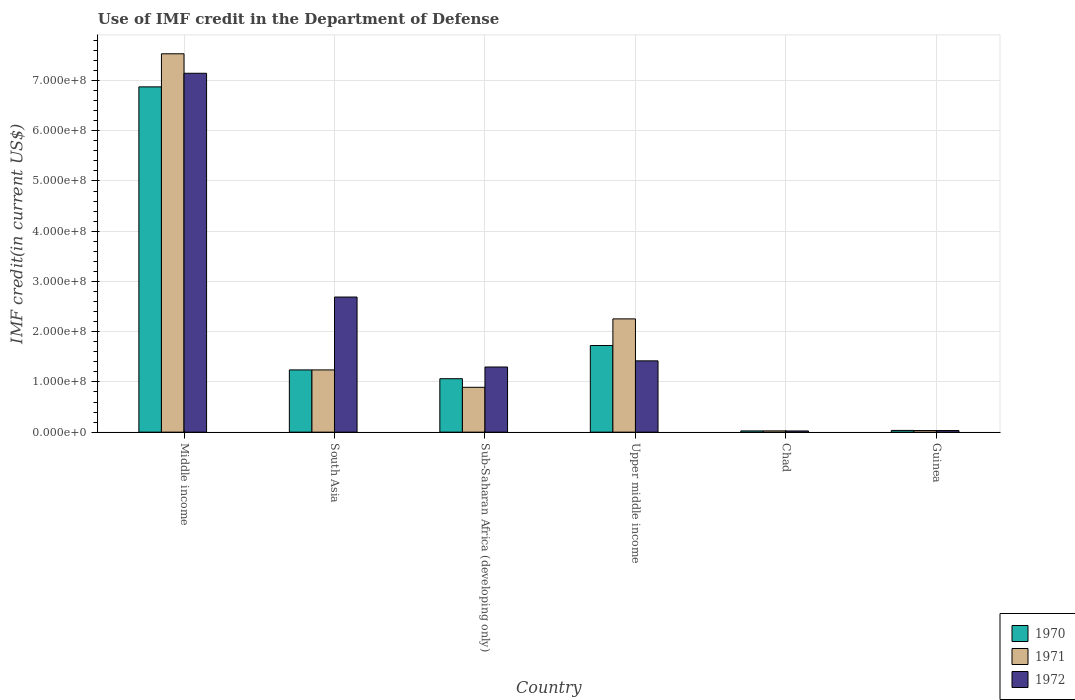How many different coloured bars are there?
Provide a succinct answer. 3. How many groups of bars are there?
Provide a short and direct response. 6. How many bars are there on the 6th tick from the right?
Provide a short and direct response. 3. What is the label of the 4th group of bars from the left?
Give a very brief answer. Upper middle income. In how many cases, is the number of bars for a given country not equal to the number of legend labels?
Make the answer very short. 0. What is the IMF credit in the Department of Defense in 1971 in Sub-Saharan Africa (developing only)?
Your response must be concise. 8.93e+07. Across all countries, what is the maximum IMF credit in the Department of Defense in 1972?
Give a very brief answer. 7.14e+08. Across all countries, what is the minimum IMF credit in the Department of Defense in 1972?
Give a very brief answer. 2.37e+06. In which country was the IMF credit in the Department of Defense in 1972 minimum?
Give a very brief answer. Chad. What is the total IMF credit in the Department of Defense in 1971 in the graph?
Make the answer very short. 1.20e+09. What is the difference between the IMF credit in the Department of Defense in 1972 in Middle income and that in Sub-Saharan Africa (developing only)?
Offer a very short reply. 5.85e+08. What is the difference between the IMF credit in the Department of Defense in 1970 in Middle income and the IMF credit in the Department of Defense in 1971 in Sub-Saharan Africa (developing only)?
Offer a terse response. 5.98e+08. What is the average IMF credit in the Department of Defense in 1972 per country?
Make the answer very short. 2.10e+08. What is the difference between the IMF credit in the Department of Defense of/in 1971 and IMF credit in the Department of Defense of/in 1972 in Upper middle income?
Your answer should be compact. 8.35e+07. In how many countries, is the IMF credit in the Department of Defense in 1972 greater than 300000000 US$?
Your answer should be very brief. 1. What is the ratio of the IMF credit in the Department of Defense in 1970 in Middle income to that in South Asia?
Ensure brevity in your answer.  5.55. Is the difference between the IMF credit in the Department of Defense in 1971 in Guinea and Sub-Saharan Africa (developing only) greater than the difference between the IMF credit in the Department of Defense in 1972 in Guinea and Sub-Saharan Africa (developing only)?
Your response must be concise. Yes. What is the difference between the highest and the second highest IMF credit in the Department of Defense in 1972?
Your answer should be compact. -4.45e+08. What is the difference between the highest and the lowest IMF credit in the Department of Defense in 1971?
Make the answer very short. 7.51e+08. Is the sum of the IMF credit in the Department of Defense in 1971 in Guinea and Middle income greater than the maximum IMF credit in the Department of Defense in 1972 across all countries?
Your response must be concise. Yes. What does the 2nd bar from the left in Sub-Saharan Africa (developing only) represents?
Make the answer very short. 1971. What does the 2nd bar from the right in Middle income represents?
Make the answer very short. 1971. Is it the case that in every country, the sum of the IMF credit in the Department of Defense in 1971 and IMF credit in the Department of Defense in 1972 is greater than the IMF credit in the Department of Defense in 1970?
Keep it short and to the point. Yes. How many bars are there?
Your answer should be very brief. 18. Are all the bars in the graph horizontal?
Give a very brief answer. No. How many countries are there in the graph?
Your response must be concise. 6. What is the difference between two consecutive major ticks on the Y-axis?
Keep it short and to the point. 1.00e+08. Are the values on the major ticks of Y-axis written in scientific E-notation?
Keep it short and to the point. Yes. Does the graph contain any zero values?
Provide a short and direct response. No. How many legend labels are there?
Make the answer very short. 3. What is the title of the graph?
Offer a terse response. Use of IMF credit in the Department of Defense. What is the label or title of the X-axis?
Make the answer very short. Country. What is the label or title of the Y-axis?
Your answer should be compact. IMF credit(in current US$). What is the IMF credit(in current US$) in 1970 in Middle income?
Ensure brevity in your answer.  6.87e+08. What is the IMF credit(in current US$) of 1971 in Middle income?
Offer a very short reply. 7.53e+08. What is the IMF credit(in current US$) in 1972 in Middle income?
Your response must be concise. 7.14e+08. What is the IMF credit(in current US$) of 1970 in South Asia?
Ensure brevity in your answer.  1.24e+08. What is the IMF credit(in current US$) in 1971 in South Asia?
Provide a short and direct response. 1.24e+08. What is the IMF credit(in current US$) of 1972 in South Asia?
Offer a terse response. 2.69e+08. What is the IMF credit(in current US$) of 1970 in Sub-Saharan Africa (developing only)?
Provide a short and direct response. 1.06e+08. What is the IMF credit(in current US$) in 1971 in Sub-Saharan Africa (developing only)?
Give a very brief answer. 8.93e+07. What is the IMF credit(in current US$) in 1972 in Sub-Saharan Africa (developing only)?
Offer a very short reply. 1.30e+08. What is the IMF credit(in current US$) in 1970 in Upper middle income?
Provide a succinct answer. 1.72e+08. What is the IMF credit(in current US$) of 1971 in Upper middle income?
Ensure brevity in your answer.  2.25e+08. What is the IMF credit(in current US$) of 1972 in Upper middle income?
Your response must be concise. 1.42e+08. What is the IMF credit(in current US$) in 1970 in Chad?
Offer a very short reply. 2.47e+06. What is the IMF credit(in current US$) in 1971 in Chad?
Your answer should be very brief. 2.52e+06. What is the IMF credit(in current US$) in 1972 in Chad?
Provide a succinct answer. 2.37e+06. What is the IMF credit(in current US$) of 1970 in Guinea?
Offer a very short reply. 3.45e+06. What is the IMF credit(in current US$) of 1971 in Guinea?
Your answer should be very brief. 3.20e+06. What is the IMF credit(in current US$) in 1972 in Guinea?
Provide a short and direct response. 3.20e+06. Across all countries, what is the maximum IMF credit(in current US$) in 1970?
Keep it short and to the point. 6.87e+08. Across all countries, what is the maximum IMF credit(in current US$) in 1971?
Offer a very short reply. 7.53e+08. Across all countries, what is the maximum IMF credit(in current US$) of 1972?
Offer a very short reply. 7.14e+08. Across all countries, what is the minimum IMF credit(in current US$) of 1970?
Your answer should be compact. 2.47e+06. Across all countries, what is the minimum IMF credit(in current US$) in 1971?
Provide a succinct answer. 2.52e+06. Across all countries, what is the minimum IMF credit(in current US$) of 1972?
Make the answer very short. 2.37e+06. What is the total IMF credit(in current US$) in 1970 in the graph?
Your response must be concise. 1.10e+09. What is the total IMF credit(in current US$) in 1971 in the graph?
Your response must be concise. 1.20e+09. What is the total IMF credit(in current US$) of 1972 in the graph?
Your answer should be very brief. 1.26e+09. What is the difference between the IMF credit(in current US$) of 1970 in Middle income and that in South Asia?
Keep it short and to the point. 5.64e+08. What is the difference between the IMF credit(in current US$) in 1971 in Middle income and that in South Asia?
Provide a succinct answer. 6.29e+08. What is the difference between the IMF credit(in current US$) of 1972 in Middle income and that in South Asia?
Ensure brevity in your answer.  4.45e+08. What is the difference between the IMF credit(in current US$) in 1970 in Middle income and that in Sub-Saharan Africa (developing only)?
Provide a short and direct response. 5.81e+08. What is the difference between the IMF credit(in current US$) of 1971 in Middle income and that in Sub-Saharan Africa (developing only)?
Make the answer very short. 6.64e+08. What is the difference between the IMF credit(in current US$) of 1972 in Middle income and that in Sub-Saharan Africa (developing only)?
Your answer should be compact. 5.85e+08. What is the difference between the IMF credit(in current US$) of 1970 in Middle income and that in Upper middle income?
Your answer should be very brief. 5.15e+08. What is the difference between the IMF credit(in current US$) in 1971 in Middle income and that in Upper middle income?
Offer a very short reply. 5.28e+08. What is the difference between the IMF credit(in current US$) in 1972 in Middle income and that in Upper middle income?
Offer a terse response. 5.73e+08. What is the difference between the IMF credit(in current US$) in 1970 in Middle income and that in Chad?
Give a very brief answer. 6.85e+08. What is the difference between the IMF credit(in current US$) in 1971 in Middle income and that in Chad?
Give a very brief answer. 7.51e+08. What is the difference between the IMF credit(in current US$) of 1972 in Middle income and that in Chad?
Offer a very short reply. 7.12e+08. What is the difference between the IMF credit(in current US$) in 1970 in Middle income and that in Guinea?
Offer a terse response. 6.84e+08. What is the difference between the IMF credit(in current US$) in 1971 in Middle income and that in Guinea?
Ensure brevity in your answer.  7.50e+08. What is the difference between the IMF credit(in current US$) in 1972 in Middle income and that in Guinea?
Your answer should be compact. 7.11e+08. What is the difference between the IMF credit(in current US$) of 1970 in South Asia and that in Sub-Saharan Africa (developing only)?
Your answer should be very brief. 1.75e+07. What is the difference between the IMF credit(in current US$) in 1971 in South Asia and that in Sub-Saharan Africa (developing only)?
Provide a short and direct response. 3.46e+07. What is the difference between the IMF credit(in current US$) in 1972 in South Asia and that in Sub-Saharan Africa (developing only)?
Provide a succinct answer. 1.39e+08. What is the difference between the IMF credit(in current US$) in 1970 in South Asia and that in Upper middle income?
Provide a succinct answer. -4.86e+07. What is the difference between the IMF credit(in current US$) of 1971 in South Asia and that in Upper middle income?
Give a very brief answer. -1.02e+08. What is the difference between the IMF credit(in current US$) in 1972 in South Asia and that in Upper middle income?
Give a very brief answer. 1.27e+08. What is the difference between the IMF credit(in current US$) of 1970 in South Asia and that in Chad?
Your answer should be compact. 1.21e+08. What is the difference between the IMF credit(in current US$) of 1971 in South Asia and that in Chad?
Make the answer very short. 1.21e+08. What is the difference between the IMF credit(in current US$) of 1972 in South Asia and that in Chad?
Your answer should be compact. 2.67e+08. What is the difference between the IMF credit(in current US$) in 1970 in South Asia and that in Guinea?
Your answer should be very brief. 1.20e+08. What is the difference between the IMF credit(in current US$) in 1971 in South Asia and that in Guinea?
Keep it short and to the point. 1.21e+08. What is the difference between the IMF credit(in current US$) in 1972 in South Asia and that in Guinea?
Your answer should be very brief. 2.66e+08. What is the difference between the IMF credit(in current US$) in 1970 in Sub-Saharan Africa (developing only) and that in Upper middle income?
Your response must be concise. -6.61e+07. What is the difference between the IMF credit(in current US$) in 1971 in Sub-Saharan Africa (developing only) and that in Upper middle income?
Your answer should be compact. -1.36e+08. What is the difference between the IMF credit(in current US$) in 1972 in Sub-Saharan Africa (developing only) and that in Upper middle income?
Keep it short and to the point. -1.23e+07. What is the difference between the IMF credit(in current US$) in 1970 in Sub-Saharan Africa (developing only) and that in Chad?
Provide a short and direct response. 1.04e+08. What is the difference between the IMF credit(in current US$) in 1971 in Sub-Saharan Africa (developing only) and that in Chad?
Ensure brevity in your answer.  8.68e+07. What is the difference between the IMF credit(in current US$) of 1972 in Sub-Saharan Africa (developing only) and that in Chad?
Offer a terse response. 1.27e+08. What is the difference between the IMF credit(in current US$) of 1970 in Sub-Saharan Africa (developing only) and that in Guinea?
Provide a short and direct response. 1.03e+08. What is the difference between the IMF credit(in current US$) in 1971 in Sub-Saharan Africa (developing only) and that in Guinea?
Your response must be concise. 8.61e+07. What is the difference between the IMF credit(in current US$) in 1972 in Sub-Saharan Africa (developing only) and that in Guinea?
Provide a short and direct response. 1.26e+08. What is the difference between the IMF credit(in current US$) of 1970 in Upper middle income and that in Chad?
Ensure brevity in your answer.  1.70e+08. What is the difference between the IMF credit(in current US$) of 1971 in Upper middle income and that in Chad?
Offer a very short reply. 2.23e+08. What is the difference between the IMF credit(in current US$) in 1972 in Upper middle income and that in Chad?
Keep it short and to the point. 1.40e+08. What is the difference between the IMF credit(in current US$) in 1970 in Upper middle income and that in Guinea?
Give a very brief answer. 1.69e+08. What is the difference between the IMF credit(in current US$) in 1971 in Upper middle income and that in Guinea?
Your response must be concise. 2.22e+08. What is the difference between the IMF credit(in current US$) of 1972 in Upper middle income and that in Guinea?
Give a very brief answer. 1.39e+08. What is the difference between the IMF credit(in current US$) in 1970 in Chad and that in Guinea?
Keep it short and to the point. -9.80e+05. What is the difference between the IMF credit(in current US$) in 1971 in Chad and that in Guinea?
Provide a succinct answer. -6.84e+05. What is the difference between the IMF credit(in current US$) in 1972 in Chad and that in Guinea?
Offer a very short reply. -8.36e+05. What is the difference between the IMF credit(in current US$) in 1970 in Middle income and the IMF credit(in current US$) in 1971 in South Asia?
Your response must be concise. 5.64e+08. What is the difference between the IMF credit(in current US$) in 1970 in Middle income and the IMF credit(in current US$) in 1972 in South Asia?
Provide a succinct answer. 4.18e+08. What is the difference between the IMF credit(in current US$) in 1971 in Middle income and the IMF credit(in current US$) in 1972 in South Asia?
Provide a succinct answer. 4.84e+08. What is the difference between the IMF credit(in current US$) in 1970 in Middle income and the IMF credit(in current US$) in 1971 in Sub-Saharan Africa (developing only)?
Offer a very short reply. 5.98e+08. What is the difference between the IMF credit(in current US$) in 1970 in Middle income and the IMF credit(in current US$) in 1972 in Sub-Saharan Africa (developing only)?
Give a very brief answer. 5.58e+08. What is the difference between the IMF credit(in current US$) in 1971 in Middle income and the IMF credit(in current US$) in 1972 in Sub-Saharan Africa (developing only)?
Ensure brevity in your answer.  6.24e+08. What is the difference between the IMF credit(in current US$) in 1970 in Middle income and the IMF credit(in current US$) in 1971 in Upper middle income?
Give a very brief answer. 4.62e+08. What is the difference between the IMF credit(in current US$) of 1970 in Middle income and the IMF credit(in current US$) of 1972 in Upper middle income?
Offer a very short reply. 5.45e+08. What is the difference between the IMF credit(in current US$) in 1971 in Middle income and the IMF credit(in current US$) in 1972 in Upper middle income?
Provide a succinct answer. 6.11e+08. What is the difference between the IMF credit(in current US$) of 1970 in Middle income and the IMF credit(in current US$) of 1971 in Chad?
Provide a succinct answer. 6.85e+08. What is the difference between the IMF credit(in current US$) of 1970 in Middle income and the IMF credit(in current US$) of 1972 in Chad?
Provide a succinct answer. 6.85e+08. What is the difference between the IMF credit(in current US$) in 1971 in Middle income and the IMF credit(in current US$) in 1972 in Chad?
Give a very brief answer. 7.51e+08. What is the difference between the IMF credit(in current US$) in 1970 in Middle income and the IMF credit(in current US$) in 1971 in Guinea?
Offer a terse response. 6.84e+08. What is the difference between the IMF credit(in current US$) in 1970 in Middle income and the IMF credit(in current US$) in 1972 in Guinea?
Offer a terse response. 6.84e+08. What is the difference between the IMF credit(in current US$) in 1971 in Middle income and the IMF credit(in current US$) in 1972 in Guinea?
Make the answer very short. 7.50e+08. What is the difference between the IMF credit(in current US$) of 1970 in South Asia and the IMF credit(in current US$) of 1971 in Sub-Saharan Africa (developing only)?
Give a very brief answer. 3.46e+07. What is the difference between the IMF credit(in current US$) in 1970 in South Asia and the IMF credit(in current US$) in 1972 in Sub-Saharan Africa (developing only)?
Make the answer very short. -5.79e+06. What is the difference between the IMF credit(in current US$) in 1971 in South Asia and the IMF credit(in current US$) in 1972 in Sub-Saharan Africa (developing only)?
Offer a very short reply. -5.79e+06. What is the difference between the IMF credit(in current US$) of 1970 in South Asia and the IMF credit(in current US$) of 1971 in Upper middle income?
Offer a terse response. -1.02e+08. What is the difference between the IMF credit(in current US$) of 1970 in South Asia and the IMF credit(in current US$) of 1972 in Upper middle income?
Your response must be concise. -1.80e+07. What is the difference between the IMF credit(in current US$) in 1971 in South Asia and the IMF credit(in current US$) in 1972 in Upper middle income?
Keep it short and to the point. -1.80e+07. What is the difference between the IMF credit(in current US$) of 1970 in South Asia and the IMF credit(in current US$) of 1971 in Chad?
Provide a succinct answer. 1.21e+08. What is the difference between the IMF credit(in current US$) in 1970 in South Asia and the IMF credit(in current US$) in 1972 in Chad?
Provide a succinct answer. 1.22e+08. What is the difference between the IMF credit(in current US$) of 1971 in South Asia and the IMF credit(in current US$) of 1972 in Chad?
Ensure brevity in your answer.  1.22e+08. What is the difference between the IMF credit(in current US$) of 1970 in South Asia and the IMF credit(in current US$) of 1971 in Guinea?
Your answer should be very brief. 1.21e+08. What is the difference between the IMF credit(in current US$) in 1970 in South Asia and the IMF credit(in current US$) in 1972 in Guinea?
Keep it short and to the point. 1.21e+08. What is the difference between the IMF credit(in current US$) in 1971 in South Asia and the IMF credit(in current US$) in 1972 in Guinea?
Offer a terse response. 1.21e+08. What is the difference between the IMF credit(in current US$) of 1970 in Sub-Saharan Africa (developing only) and the IMF credit(in current US$) of 1971 in Upper middle income?
Your answer should be very brief. -1.19e+08. What is the difference between the IMF credit(in current US$) in 1970 in Sub-Saharan Africa (developing only) and the IMF credit(in current US$) in 1972 in Upper middle income?
Your answer should be very brief. -3.56e+07. What is the difference between the IMF credit(in current US$) in 1971 in Sub-Saharan Africa (developing only) and the IMF credit(in current US$) in 1972 in Upper middle income?
Your response must be concise. -5.27e+07. What is the difference between the IMF credit(in current US$) of 1970 in Sub-Saharan Africa (developing only) and the IMF credit(in current US$) of 1971 in Chad?
Ensure brevity in your answer.  1.04e+08. What is the difference between the IMF credit(in current US$) of 1970 in Sub-Saharan Africa (developing only) and the IMF credit(in current US$) of 1972 in Chad?
Ensure brevity in your answer.  1.04e+08. What is the difference between the IMF credit(in current US$) in 1971 in Sub-Saharan Africa (developing only) and the IMF credit(in current US$) in 1972 in Chad?
Offer a terse response. 8.69e+07. What is the difference between the IMF credit(in current US$) of 1970 in Sub-Saharan Africa (developing only) and the IMF credit(in current US$) of 1971 in Guinea?
Provide a succinct answer. 1.03e+08. What is the difference between the IMF credit(in current US$) of 1970 in Sub-Saharan Africa (developing only) and the IMF credit(in current US$) of 1972 in Guinea?
Make the answer very short. 1.03e+08. What is the difference between the IMF credit(in current US$) of 1971 in Sub-Saharan Africa (developing only) and the IMF credit(in current US$) of 1972 in Guinea?
Your response must be concise. 8.61e+07. What is the difference between the IMF credit(in current US$) of 1970 in Upper middle income and the IMF credit(in current US$) of 1971 in Chad?
Provide a succinct answer. 1.70e+08. What is the difference between the IMF credit(in current US$) of 1970 in Upper middle income and the IMF credit(in current US$) of 1972 in Chad?
Ensure brevity in your answer.  1.70e+08. What is the difference between the IMF credit(in current US$) in 1971 in Upper middle income and the IMF credit(in current US$) in 1972 in Chad?
Make the answer very short. 2.23e+08. What is the difference between the IMF credit(in current US$) of 1970 in Upper middle income and the IMF credit(in current US$) of 1971 in Guinea?
Make the answer very short. 1.69e+08. What is the difference between the IMF credit(in current US$) in 1970 in Upper middle income and the IMF credit(in current US$) in 1972 in Guinea?
Your response must be concise. 1.69e+08. What is the difference between the IMF credit(in current US$) of 1971 in Upper middle income and the IMF credit(in current US$) of 1972 in Guinea?
Ensure brevity in your answer.  2.22e+08. What is the difference between the IMF credit(in current US$) in 1970 in Chad and the IMF credit(in current US$) in 1971 in Guinea?
Your answer should be compact. -7.33e+05. What is the difference between the IMF credit(in current US$) of 1970 in Chad and the IMF credit(in current US$) of 1972 in Guinea?
Provide a short and direct response. -7.33e+05. What is the difference between the IMF credit(in current US$) in 1971 in Chad and the IMF credit(in current US$) in 1972 in Guinea?
Ensure brevity in your answer.  -6.84e+05. What is the average IMF credit(in current US$) of 1970 per country?
Ensure brevity in your answer.  1.83e+08. What is the average IMF credit(in current US$) in 1971 per country?
Provide a short and direct response. 2.00e+08. What is the average IMF credit(in current US$) in 1972 per country?
Ensure brevity in your answer.  2.10e+08. What is the difference between the IMF credit(in current US$) of 1970 and IMF credit(in current US$) of 1971 in Middle income?
Provide a short and direct response. -6.58e+07. What is the difference between the IMF credit(in current US$) of 1970 and IMF credit(in current US$) of 1972 in Middle income?
Make the answer very short. -2.71e+07. What is the difference between the IMF credit(in current US$) in 1971 and IMF credit(in current US$) in 1972 in Middle income?
Keep it short and to the point. 3.88e+07. What is the difference between the IMF credit(in current US$) in 1970 and IMF credit(in current US$) in 1972 in South Asia?
Your response must be concise. -1.45e+08. What is the difference between the IMF credit(in current US$) of 1971 and IMF credit(in current US$) of 1972 in South Asia?
Your answer should be very brief. -1.45e+08. What is the difference between the IMF credit(in current US$) of 1970 and IMF credit(in current US$) of 1971 in Sub-Saharan Africa (developing only)?
Keep it short and to the point. 1.71e+07. What is the difference between the IMF credit(in current US$) of 1970 and IMF credit(in current US$) of 1972 in Sub-Saharan Africa (developing only)?
Your response must be concise. -2.33e+07. What is the difference between the IMF credit(in current US$) in 1971 and IMF credit(in current US$) in 1972 in Sub-Saharan Africa (developing only)?
Give a very brief answer. -4.04e+07. What is the difference between the IMF credit(in current US$) of 1970 and IMF credit(in current US$) of 1971 in Upper middle income?
Your answer should be compact. -5.30e+07. What is the difference between the IMF credit(in current US$) of 1970 and IMF credit(in current US$) of 1972 in Upper middle income?
Your answer should be compact. 3.05e+07. What is the difference between the IMF credit(in current US$) in 1971 and IMF credit(in current US$) in 1972 in Upper middle income?
Provide a succinct answer. 8.35e+07. What is the difference between the IMF credit(in current US$) in 1970 and IMF credit(in current US$) in 1971 in Chad?
Ensure brevity in your answer.  -4.90e+04. What is the difference between the IMF credit(in current US$) of 1970 and IMF credit(in current US$) of 1972 in Chad?
Keep it short and to the point. 1.03e+05. What is the difference between the IMF credit(in current US$) in 1971 and IMF credit(in current US$) in 1972 in Chad?
Provide a short and direct response. 1.52e+05. What is the difference between the IMF credit(in current US$) of 1970 and IMF credit(in current US$) of 1971 in Guinea?
Your answer should be compact. 2.47e+05. What is the difference between the IMF credit(in current US$) of 1970 and IMF credit(in current US$) of 1972 in Guinea?
Keep it short and to the point. 2.47e+05. What is the ratio of the IMF credit(in current US$) of 1970 in Middle income to that in South Asia?
Provide a succinct answer. 5.55. What is the ratio of the IMF credit(in current US$) of 1971 in Middle income to that in South Asia?
Offer a terse response. 6.08. What is the ratio of the IMF credit(in current US$) of 1972 in Middle income to that in South Asia?
Offer a terse response. 2.66. What is the ratio of the IMF credit(in current US$) in 1970 in Middle income to that in Sub-Saharan Africa (developing only)?
Your answer should be very brief. 6.46. What is the ratio of the IMF credit(in current US$) in 1971 in Middle income to that in Sub-Saharan Africa (developing only)?
Give a very brief answer. 8.44. What is the ratio of the IMF credit(in current US$) in 1972 in Middle income to that in Sub-Saharan Africa (developing only)?
Make the answer very short. 5.51. What is the ratio of the IMF credit(in current US$) of 1970 in Middle income to that in Upper middle income?
Provide a short and direct response. 3.99. What is the ratio of the IMF credit(in current US$) in 1971 in Middle income to that in Upper middle income?
Provide a short and direct response. 3.34. What is the ratio of the IMF credit(in current US$) in 1972 in Middle income to that in Upper middle income?
Provide a short and direct response. 5.03. What is the ratio of the IMF credit(in current US$) in 1970 in Middle income to that in Chad?
Provide a succinct answer. 278.3. What is the ratio of the IMF credit(in current US$) in 1971 in Middle income to that in Chad?
Ensure brevity in your answer.  299.03. What is the ratio of the IMF credit(in current US$) of 1972 in Middle income to that in Chad?
Give a very brief answer. 301.85. What is the ratio of the IMF credit(in current US$) in 1970 in Middle income to that in Guinea?
Offer a terse response. 199.25. What is the ratio of the IMF credit(in current US$) of 1971 in Middle income to that in Guinea?
Provide a short and direct response. 235.17. What is the ratio of the IMF credit(in current US$) in 1972 in Middle income to that in Guinea?
Your answer should be compact. 223.06. What is the ratio of the IMF credit(in current US$) of 1970 in South Asia to that in Sub-Saharan Africa (developing only)?
Your answer should be compact. 1.16. What is the ratio of the IMF credit(in current US$) of 1971 in South Asia to that in Sub-Saharan Africa (developing only)?
Your answer should be very brief. 1.39. What is the ratio of the IMF credit(in current US$) of 1972 in South Asia to that in Sub-Saharan Africa (developing only)?
Keep it short and to the point. 2.07. What is the ratio of the IMF credit(in current US$) in 1970 in South Asia to that in Upper middle income?
Make the answer very short. 0.72. What is the ratio of the IMF credit(in current US$) in 1971 in South Asia to that in Upper middle income?
Provide a succinct answer. 0.55. What is the ratio of the IMF credit(in current US$) in 1972 in South Asia to that in Upper middle income?
Your answer should be very brief. 1.9. What is the ratio of the IMF credit(in current US$) of 1970 in South Asia to that in Chad?
Ensure brevity in your answer.  50.16. What is the ratio of the IMF credit(in current US$) of 1971 in South Asia to that in Chad?
Provide a short and direct response. 49.19. What is the ratio of the IMF credit(in current US$) in 1972 in South Asia to that in Chad?
Your answer should be compact. 113.64. What is the ratio of the IMF credit(in current US$) of 1970 in South Asia to that in Guinea?
Make the answer very short. 35.91. What is the ratio of the IMF credit(in current US$) of 1971 in South Asia to that in Guinea?
Keep it short and to the point. 38.68. What is the ratio of the IMF credit(in current US$) of 1972 in South Asia to that in Guinea?
Ensure brevity in your answer.  83.98. What is the ratio of the IMF credit(in current US$) of 1970 in Sub-Saharan Africa (developing only) to that in Upper middle income?
Ensure brevity in your answer.  0.62. What is the ratio of the IMF credit(in current US$) in 1971 in Sub-Saharan Africa (developing only) to that in Upper middle income?
Your response must be concise. 0.4. What is the ratio of the IMF credit(in current US$) in 1972 in Sub-Saharan Africa (developing only) to that in Upper middle income?
Your answer should be compact. 0.91. What is the ratio of the IMF credit(in current US$) of 1970 in Sub-Saharan Africa (developing only) to that in Chad?
Offer a terse response. 43.07. What is the ratio of the IMF credit(in current US$) in 1971 in Sub-Saharan Africa (developing only) to that in Chad?
Keep it short and to the point. 35.45. What is the ratio of the IMF credit(in current US$) in 1972 in Sub-Saharan Africa (developing only) to that in Chad?
Your answer should be very brief. 54.79. What is the ratio of the IMF credit(in current US$) of 1970 in Sub-Saharan Africa (developing only) to that in Guinea?
Make the answer very short. 30.84. What is the ratio of the IMF credit(in current US$) of 1971 in Sub-Saharan Africa (developing only) to that in Guinea?
Offer a terse response. 27.88. What is the ratio of the IMF credit(in current US$) in 1972 in Sub-Saharan Africa (developing only) to that in Guinea?
Offer a terse response. 40.49. What is the ratio of the IMF credit(in current US$) of 1970 in Upper middle income to that in Chad?
Give a very brief answer. 69.82. What is the ratio of the IMF credit(in current US$) in 1971 in Upper middle income to that in Chad?
Ensure brevity in your answer.  89.51. What is the ratio of the IMF credit(in current US$) of 1972 in Upper middle income to that in Chad?
Provide a short and direct response. 59.97. What is the ratio of the IMF credit(in current US$) in 1970 in Upper middle income to that in Guinea?
Give a very brief answer. 49.99. What is the ratio of the IMF credit(in current US$) in 1971 in Upper middle income to that in Guinea?
Provide a succinct answer. 70.4. What is the ratio of the IMF credit(in current US$) in 1972 in Upper middle income to that in Guinea?
Ensure brevity in your answer.  44.32. What is the ratio of the IMF credit(in current US$) of 1970 in Chad to that in Guinea?
Your answer should be compact. 0.72. What is the ratio of the IMF credit(in current US$) of 1971 in Chad to that in Guinea?
Make the answer very short. 0.79. What is the ratio of the IMF credit(in current US$) in 1972 in Chad to that in Guinea?
Keep it short and to the point. 0.74. What is the difference between the highest and the second highest IMF credit(in current US$) in 1970?
Keep it short and to the point. 5.15e+08. What is the difference between the highest and the second highest IMF credit(in current US$) in 1971?
Your answer should be very brief. 5.28e+08. What is the difference between the highest and the second highest IMF credit(in current US$) of 1972?
Provide a succinct answer. 4.45e+08. What is the difference between the highest and the lowest IMF credit(in current US$) of 1970?
Offer a terse response. 6.85e+08. What is the difference between the highest and the lowest IMF credit(in current US$) of 1971?
Your answer should be compact. 7.51e+08. What is the difference between the highest and the lowest IMF credit(in current US$) of 1972?
Provide a succinct answer. 7.12e+08. 